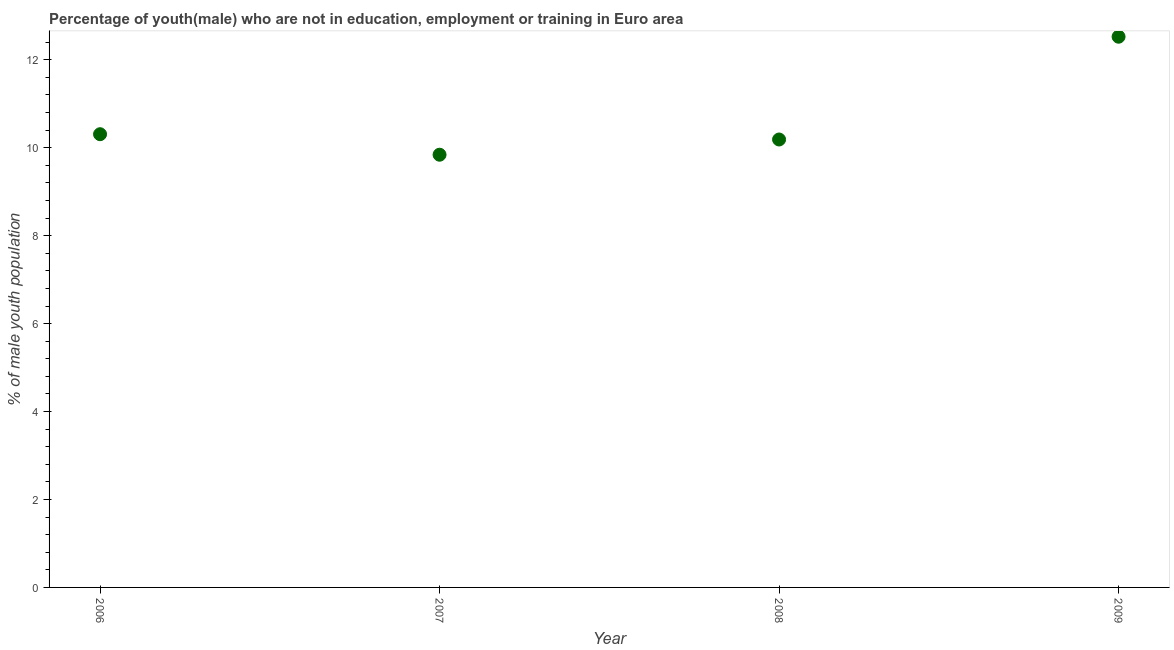What is the unemployed male youth population in 2006?
Provide a succinct answer. 10.31. Across all years, what is the maximum unemployed male youth population?
Ensure brevity in your answer.  12.52. Across all years, what is the minimum unemployed male youth population?
Your response must be concise. 9.84. In which year was the unemployed male youth population maximum?
Your answer should be compact. 2009. In which year was the unemployed male youth population minimum?
Provide a succinct answer. 2007. What is the sum of the unemployed male youth population?
Offer a terse response. 42.86. What is the difference between the unemployed male youth population in 2007 and 2008?
Your answer should be very brief. -0.35. What is the average unemployed male youth population per year?
Your answer should be compact. 10.72. What is the median unemployed male youth population?
Give a very brief answer. 10.25. What is the ratio of the unemployed male youth population in 2006 to that in 2007?
Offer a terse response. 1.05. What is the difference between the highest and the second highest unemployed male youth population?
Make the answer very short. 2.22. What is the difference between the highest and the lowest unemployed male youth population?
Make the answer very short. 2.68. In how many years, is the unemployed male youth population greater than the average unemployed male youth population taken over all years?
Offer a terse response. 1. How many dotlines are there?
Your answer should be very brief. 1. How many years are there in the graph?
Your answer should be compact. 4. What is the difference between two consecutive major ticks on the Y-axis?
Make the answer very short. 2. Does the graph contain any zero values?
Ensure brevity in your answer.  No. Does the graph contain grids?
Provide a succinct answer. No. What is the title of the graph?
Your answer should be compact. Percentage of youth(male) who are not in education, employment or training in Euro area. What is the label or title of the X-axis?
Ensure brevity in your answer.  Year. What is the label or title of the Y-axis?
Ensure brevity in your answer.  % of male youth population. What is the % of male youth population in 2006?
Your answer should be very brief. 10.31. What is the % of male youth population in 2007?
Give a very brief answer. 9.84. What is the % of male youth population in 2008?
Offer a terse response. 10.19. What is the % of male youth population in 2009?
Keep it short and to the point. 12.52. What is the difference between the % of male youth population in 2006 and 2007?
Provide a succinct answer. 0.47. What is the difference between the % of male youth population in 2006 and 2008?
Offer a very short reply. 0.12. What is the difference between the % of male youth population in 2006 and 2009?
Provide a succinct answer. -2.22. What is the difference between the % of male youth population in 2007 and 2008?
Your answer should be very brief. -0.35. What is the difference between the % of male youth population in 2007 and 2009?
Provide a succinct answer. -2.68. What is the difference between the % of male youth population in 2008 and 2009?
Offer a very short reply. -2.34. What is the ratio of the % of male youth population in 2006 to that in 2007?
Your response must be concise. 1.05. What is the ratio of the % of male youth population in 2006 to that in 2008?
Your answer should be compact. 1.01. What is the ratio of the % of male youth population in 2006 to that in 2009?
Provide a succinct answer. 0.82. What is the ratio of the % of male youth population in 2007 to that in 2009?
Provide a succinct answer. 0.79. What is the ratio of the % of male youth population in 2008 to that in 2009?
Offer a terse response. 0.81. 